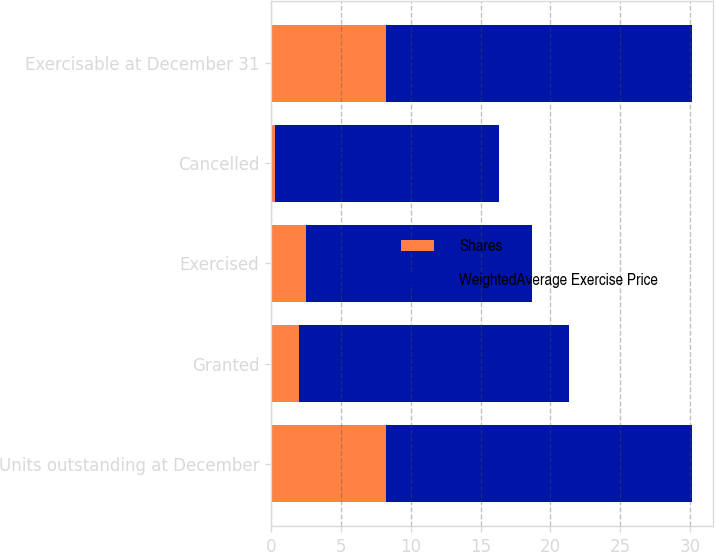<chart> <loc_0><loc_0><loc_500><loc_500><stacked_bar_chart><ecel><fcel>Units outstanding at December<fcel>Granted<fcel>Exercised<fcel>Cancelled<fcel>Exercisable at December 31<nl><fcel>Shares<fcel>8.2<fcel>2<fcel>2.5<fcel>0.3<fcel>8.2<nl><fcel>WeightedAverage Exercise Price<fcel>21.94<fcel>19.3<fcel>16.21<fcel>16.02<fcel>21.94<nl></chart> 